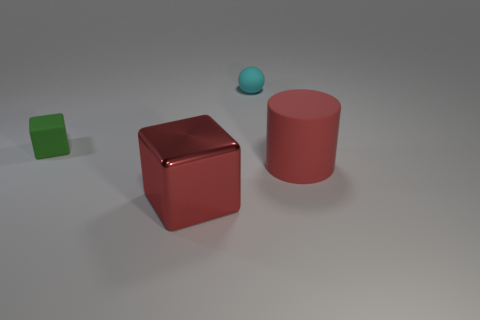There is another big object that is the same color as the large metallic object; what is its shape?
Your answer should be very brief. Cylinder. Are there any other things that have the same material as the red block?
Your response must be concise. No. What is the color of the big matte cylinder?
Offer a terse response. Red. What number of other things are there of the same size as the red rubber thing?
Provide a succinct answer. 1. What material is the thing that is behind the red cylinder and on the left side of the small rubber sphere?
Provide a short and direct response. Rubber. Is the size of the block in front of the rubber cylinder the same as the small green rubber cube?
Offer a terse response. No. Does the metallic thing have the same color as the matte cylinder?
Your response must be concise. Yes. How many objects are in front of the small cyan sphere and behind the large block?
Your answer should be very brief. 2. How many cyan things are in front of the matte object that is on the left side of the large red object that is in front of the red cylinder?
Provide a short and direct response. 0. What size is the block that is the same color as the cylinder?
Offer a terse response. Large. 